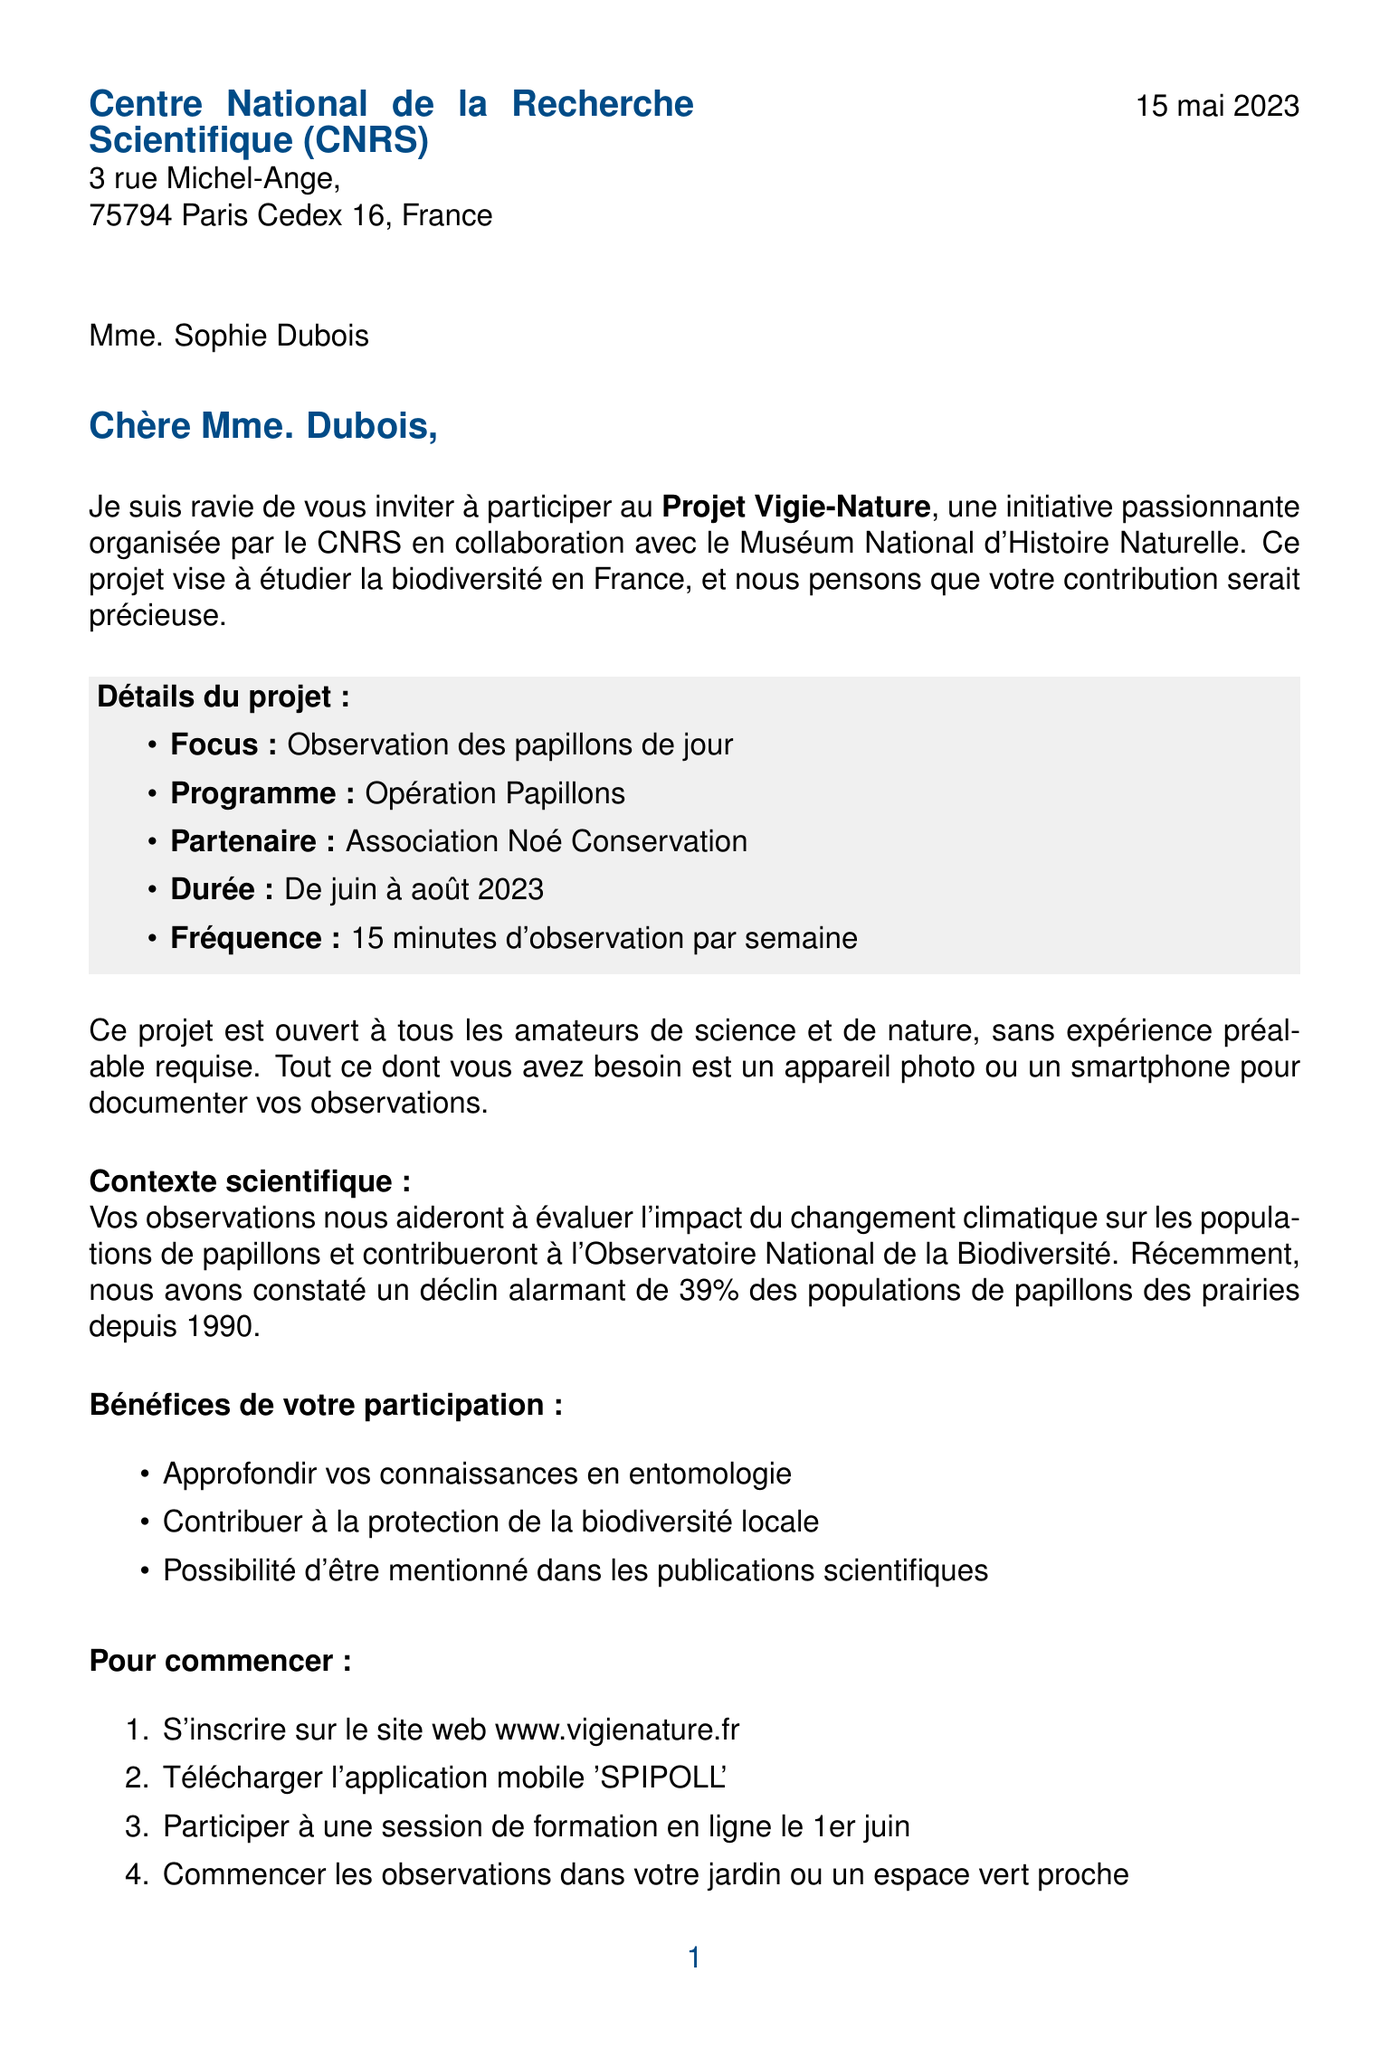What is the name of the project? The project's name is mentioned in the introduction of the letter as "Projet Vigie-Nature."
Answer: Projet Vigie-Nature Who organized the project? The organizer of the project is indicated as CNRS in collaboration with Muséum National d'Histoire Naturelle.
Answer: CNRS When does the project take place? The duration of the project is specified as June to August 2023.
Answer: De juin à août 2023 What is one focus area of the project? The focus area of the project is explained to be the observation of day butterflies.
Answer: Observation des papillons de jour What is the required frequency of participation? The document states that participants should observe for 15 minutes each week.
Answer: 15 minutes d'observation par semaine What is the prior experience required for participants? It is mentioned that no prior experience is required to participate in the project.
Answer: Aucune expérience préalable requise What do participants need to document their observations? Participants need a camera or smartphone to document their observations according to the document.
Answer: Appareil photo ou smartphone What is a benefit of participation mentioned in the letter? One benefit mentioned is the opportunity to deepen knowledge in entomology.
Answer: Approfondir vos connaissances en entomologie How can someone start participating in the project? The first step is to register on the website www.vigienature.fr.
Answer: S'inscrire sur le site web www.vigienature.fr 